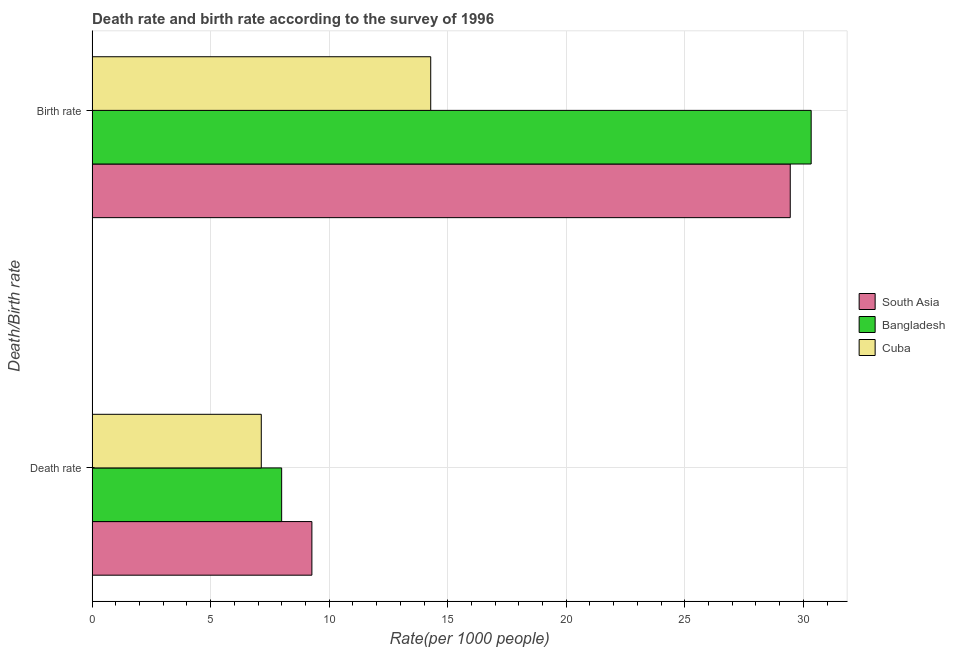How many different coloured bars are there?
Your answer should be very brief. 3. Are the number of bars on each tick of the Y-axis equal?
Provide a succinct answer. Yes. What is the label of the 2nd group of bars from the top?
Your response must be concise. Death rate. What is the birth rate in South Asia?
Offer a terse response. 29.45. Across all countries, what is the maximum death rate?
Provide a short and direct response. 9.27. Across all countries, what is the minimum birth rate?
Provide a succinct answer. 14.28. In which country was the death rate minimum?
Your answer should be compact. Cuba. What is the total death rate in the graph?
Offer a very short reply. 24.4. What is the difference between the death rate in Bangladesh and that in Cuba?
Provide a succinct answer. 0.86. What is the difference between the birth rate in Cuba and the death rate in South Asia?
Give a very brief answer. 5.01. What is the average birth rate per country?
Provide a succinct answer. 24.69. What is the difference between the birth rate and death rate in Cuba?
Offer a terse response. 7.15. What is the ratio of the birth rate in Cuba to that in South Asia?
Offer a very short reply. 0.49. What does the 2nd bar from the top in Birth rate represents?
Ensure brevity in your answer.  Bangladesh. What does the 1st bar from the bottom in Birth rate represents?
Your answer should be compact. South Asia. How many bars are there?
Your answer should be very brief. 6. Are all the bars in the graph horizontal?
Offer a very short reply. Yes. How many countries are there in the graph?
Provide a short and direct response. 3. Are the values on the major ticks of X-axis written in scientific E-notation?
Provide a short and direct response. No. Does the graph contain grids?
Provide a short and direct response. Yes. Where does the legend appear in the graph?
Give a very brief answer. Center right. How are the legend labels stacked?
Provide a short and direct response. Vertical. What is the title of the graph?
Your response must be concise. Death rate and birth rate according to the survey of 1996. What is the label or title of the X-axis?
Offer a terse response. Rate(per 1000 people). What is the label or title of the Y-axis?
Your response must be concise. Death/Birth rate. What is the Rate(per 1000 people) in South Asia in Death rate?
Offer a terse response. 9.27. What is the Rate(per 1000 people) in Bangladesh in Death rate?
Keep it short and to the point. 8. What is the Rate(per 1000 people) of Cuba in Death rate?
Your answer should be compact. 7.14. What is the Rate(per 1000 people) in South Asia in Birth rate?
Provide a succinct answer. 29.45. What is the Rate(per 1000 people) in Bangladesh in Birth rate?
Your response must be concise. 30.33. What is the Rate(per 1000 people) of Cuba in Birth rate?
Keep it short and to the point. 14.28. Across all Death/Birth rate, what is the maximum Rate(per 1000 people) in South Asia?
Keep it short and to the point. 29.45. Across all Death/Birth rate, what is the maximum Rate(per 1000 people) in Bangladesh?
Give a very brief answer. 30.33. Across all Death/Birth rate, what is the maximum Rate(per 1000 people) in Cuba?
Your answer should be very brief. 14.28. Across all Death/Birth rate, what is the minimum Rate(per 1000 people) in South Asia?
Give a very brief answer. 9.27. Across all Death/Birth rate, what is the minimum Rate(per 1000 people) in Bangladesh?
Keep it short and to the point. 8. Across all Death/Birth rate, what is the minimum Rate(per 1000 people) of Cuba?
Provide a succinct answer. 7.14. What is the total Rate(per 1000 people) of South Asia in the graph?
Your answer should be very brief. 38.72. What is the total Rate(per 1000 people) of Bangladesh in the graph?
Give a very brief answer. 38.33. What is the total Rate(per 1000 people) in Cuba in the graph?
Your answer should be compact. 21.42. What is the difference between the Rate(per 1000 people) of South Asia in Death rate and that in Birth rate?
Provide a succinct answer. -20.18. What is the difference between the Rate(per 1000 people) of Bangladesh in Death rate and that in Birth rate?
Provide a short and direct response. -22.34. What is the difference between the Rate(per 1000 people) in Cuba in Death rate and that in Birth rate?
Ensure brevity in your answer.  -7.15. What is the difference between the Rate(per 1000 people) of South Asia in Death rate and the Rate(per 1000 people) of Bangladesh in Birth rate?
Offer a very short reply. -21.06. What is the difference between the Rate(per 1000 people) in South Asia in Death rate and the Rate(per 1000 people) in Cuba in Birth rate?
Your answer should be compact. -5.01. What is the difference between the Rate(per 1000 people) in Bangladesh in Death rate and the Rate(per 1000 people) in Cuba in Birth rate?
Offer a terse response. -6.29. What is the average Rate(per 1000 people) of South Asia per Death/Birth rate?
Provide a short and direct response. 19.36. What is the average Rate(per 1000 people) in Bangladesh per Death/Birth rate?
Offer a terse response. 19.16. What is the average Rate(per 1000 people) in Cuba per Death/Birth rate?
Offer a very short reply. 10.71. What is the difference between the Rate(per 1000 people) in South Asia and Rate(per 1000 people) in Bangladesh in Death rate?
Offer a very short reply. 1.28. What is the difference between the Rate(per 1000 people) in South Asia and Rate(per 1000 people) in Cuba in Death rate?
Ensure brevity in your answer.  2.14. What is the difference between the Rate(per 1000 people) of Bangladesh and Rate(per 1000 people) of Cuba in Death rate?
Offer a very short reply. 0.86. What is the difference between the Rate(per 1000 people) of South Asia and Rate(per 1000 people) of Bangladesh in Birth rate?
Make the answer very short. -0.88. What is the difference between the Rate(per 1000 people) of South Asia and Rate(per 1000 people) of Cuba in Birth rate?
Provide a succinct answer. 15.17. What is the difference between the Rate(per 1000 people) of Bangladesh and Rate(per 1000 people) of Cuba in Birth rate?
Ensure brevity in your answer.  16.05. What is the ratio of the Rate(per 1000 people) in South Asia in Death rate to that in Birth rate?
Your answer should be very brief. 0.31. What is the ratio of the Rate(per 1000 people) in Bangladesh in Death rate to that in Birth rate?
Your response must be concise. 0.26. What is the ratio of the Rate(per 1000 people) of Cuba in Death rate to that in Birth rate?
Provide a short and direct response. 0.5. What is the difference between the highest and the second highest Rate(per 1000 people) of South Asia?
Provide a succinct answer. 20.18. What is the difference between the highest and the second highest Rate(per 1000 people) of Bangladesh?
Your answer should be very brief. 22.34. What is the difference between the highest and the second highest Rate(per 1000 people) in Cuba?
Offer a very short reply. 7.15. What is the difference between the highest and the lowest Rate(per 1000 people) of South Asia?
Offer a terse response. 20.18. What is the difference between the highest and the lowest Rate(per 1000 people) in Bangladesh?
Offer a very short reply. 22.34. What is the difference between the highest and the lowest Rate(per 1000 people) of Cuba?
Make the answer very short. 7.15. 